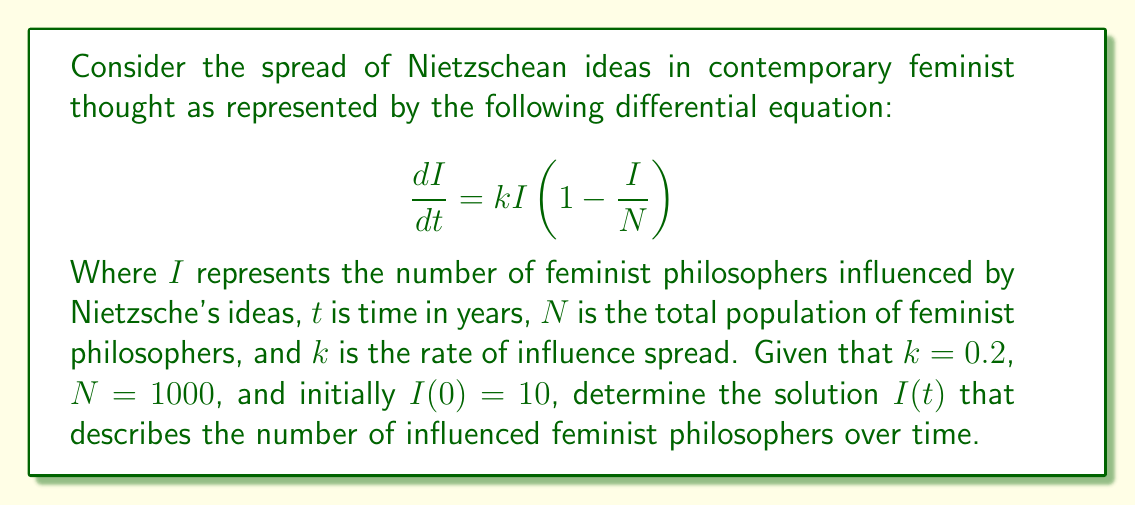Solve this math problem. To solve this differential equation, we can follow these steps:

1) First, recognize that this is a logistic differential equation of the form:

   $$\frac{dI}{dt} = kI(1-\frac{I}{N})$$

2) The solution to this type of equation is given by:

   $$I(t) = \frac{N}{1 + Ce^{-kt}}$$

   Where $C$ is a constant we need to determine.

3) To find $C$, we use the initial condition $I(0) = 10$:

   $$10 = \frac{1000}{1 + C}$$

4) Solving for $C$:

   $$C = \frac{1000}{10} - 1 = 99$$

5) Now we can write our full solution:

   $$I(t) = \frac{1000}{1 + 99e^{-0.2t}}$$

This solution represents the number of feminist philosophers influenced by Nietzsche's ideas over time, starting from 10 and approaching the total population of 1000 as $t$ increases.

From a philosophical perspective, this model suggests that Nietzschean ideas spread through the feminist philosophy community in a way that is initially slow, then accelerates, and finally slows down as it approaches saturation. This could reflect the initial resistance to Nietzsche's often misunderstood ideas, followed by a period of rapid adoption as his work is reinterpreted through a feminist lens, and finally a slowing as most feminist philosophers have engaged with his ideas in some way.
Answer: $$I(t) = \frac{1000}{1 + 99e^{-0.2t}}$$ 